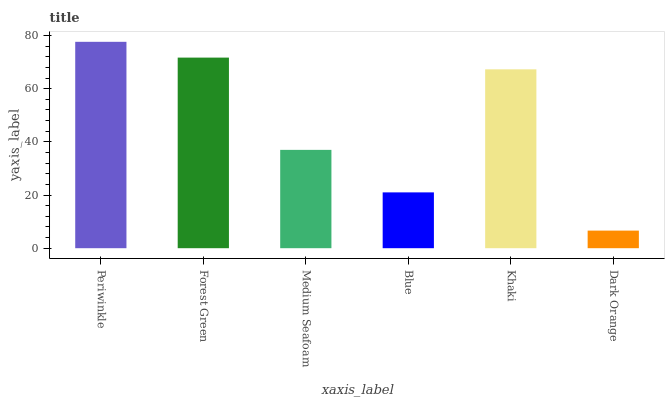Is Dark Orange the minimum?
Answer yes or no. Yes. Is Periwinkle the maximum?
Answer yes or no. Yes. Is Forest Green the minimum?
Answer yes or no. No. Is Forest Green the maximum?
Answer yes or no. No. Is Periwinkle greater than Forest Green?
Answer yes or no. Yes. Is Forest Green less than Periwinkle?
Answer yes or no. Yes. Is Forest Green greater than Periwinkle?
Answer yes or no. No. Is Periwinkle less than Forest Green?
Answer yes or no. No. Is Khaki the high median?
Answer yes or no. Yes. Is Medium Seafoam the low median?
Answer yes or no. Yes. Is Forest Green the high median?
Answer yes or no. No. Is Periwinkle the low median?
Answer yes or no. No. 